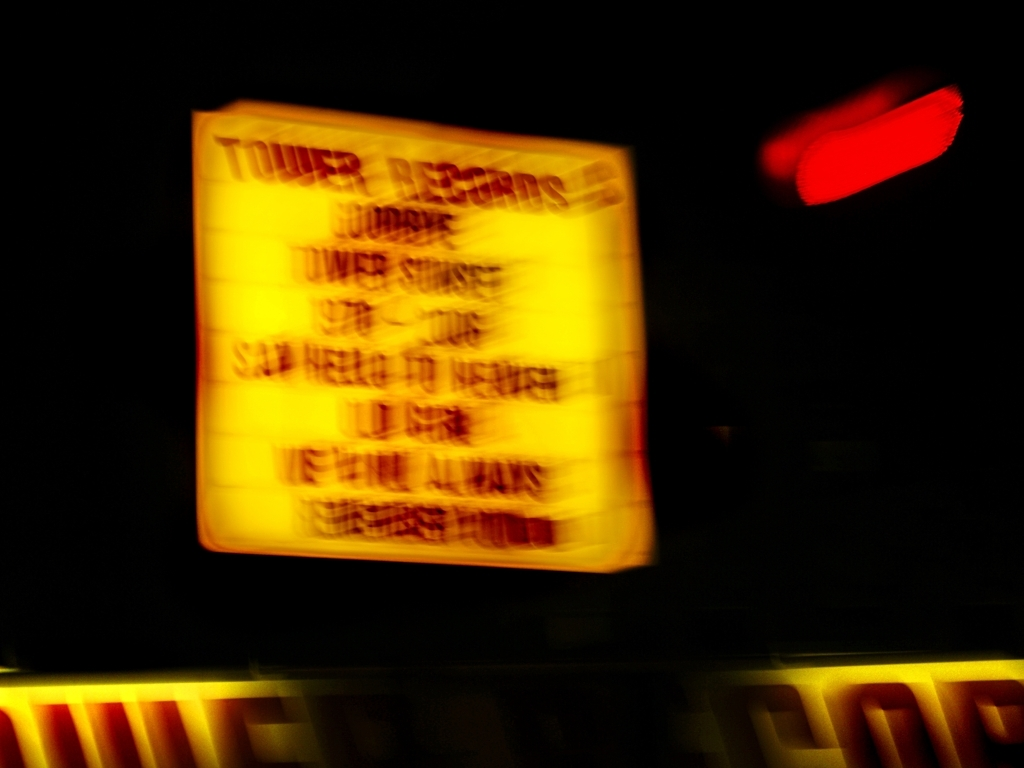What kind of place or establishment do you think is depicted in this image? Considering that we can discern the words 'TOWER RECORDS' with some effort, it suggests that the image depicts a sign for a record store or music establishment, typically a place where one might purchase music albums, CDs, or related items. 